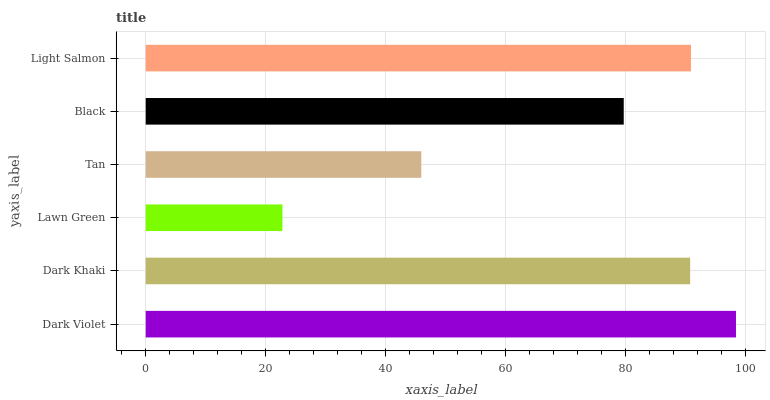Is Lawn Green the minimum?
Answer yes or no. Yes. Is Dark Violet the maximum?
Answer yes or no. Yes. Is Dark Khaki the minimum?
Answer yes or no. No. Is Dark Khaki the maximum?
Answer yes or no. No. Is Dark Violet greater than Dark Khaki?
Answer yes or no. Yes. Is Dark Khaki less than Dark Violet?
Answer yes or no. Yes. Is Dark Khaki greater than Dark Violet?
Answer yes or no. No. Is Dark Violet less than Dark Khaki?
Answer yes or no. No. Is Dark Khaki the high median?
Answer yes or no. Yes. Is Black the low median?
Answer yes or no. Yes. Is Black the high median?
Answer yes or no. No. Is Lawn Green the low median?
Answer yes or no. No. 